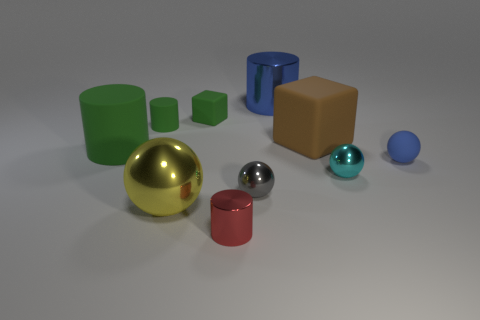Does the green cube have the same size as the gray shiny ball? While the green cube and the gray shiny ball might appear similar in size at first glance, upon closer inspection of their dimensions relative to other objects in the image, they may not be exactly the same size. Factors such as perspective and the objects' relative distances from the viewer could affect how we perceive their sizes. 